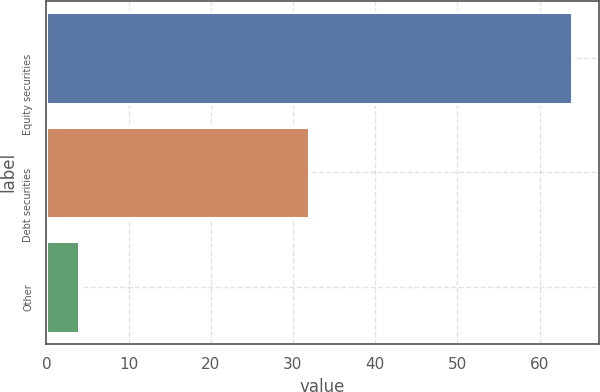<chart> <loc_0><loc_0><loc_500><loc_500><bar_chart><fcel>Equity securities<fcel>Debt securities<fcel>Other<nl><fcel>64<fcel>32<fcel>4<nl></chart> 